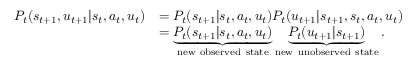Convert formula to latex. <formula><loc_0><loc_0><loc_500><loc_500>\begin{array} { r l } { P _ { t } ( s _ { t + 1 } , u _ { t + 1 } | s _ { t } , a _ { t } , u _ { t } ) } & { = P _ { t } ( s _ { t + 1 } | s _ { t } , a _ { t } , u _ { t } ) P _ { t } ( u _ { t + 1 } | s _ { t + 1 } , s _ { t } , a _ { t } , u _ { t } ) } \\ & { = \underbrace { P _ { t } ( s _ { t + 1 } | s _ { t } , a _ { t } , u _ { t } ) } _ { n e w o b s e r v e d s t a t e } \underbrace { P _ { t } ( u _ { t + 1 } | s _ { t + 1 } ) } _ { n e w u n o b s e r v e d s t a t e } . } \end{array}</formula> 